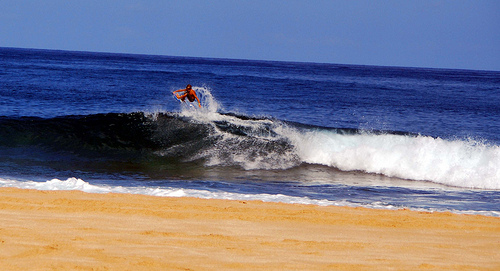Please provide the bounding box coordinate of the region this sentence describes: Blue water in ocean. [0.76, 0.41, 0.86, 0.49] Please provide the bounding box coordinate of the region this sentence describes: Top of wave is white. [0.83, 0.52, 0.9, 0.59] Please provide a short description for this region: [0.12, 0.63, 0.2, 0.71]. Tan sandy beach near water. Please provide the bounding box coordinate of the region this sentence describes: a man surfing the wave. [0.27, 0.36, 0.61, 0.61] Please provide the bounding box coordinate of the region this sentence describes: a man riding the wave. [0.33, 0.36, 0.6, 0.66] Please provide the bounding box coordinate of the region this sentence describes: Man standing on top of surfboard. [0.34, 0.4, 0.39, 0.45] Please provide a short description for this region: [0.26, 0.31, 0.64, 0.6]. A man that is surfing. 